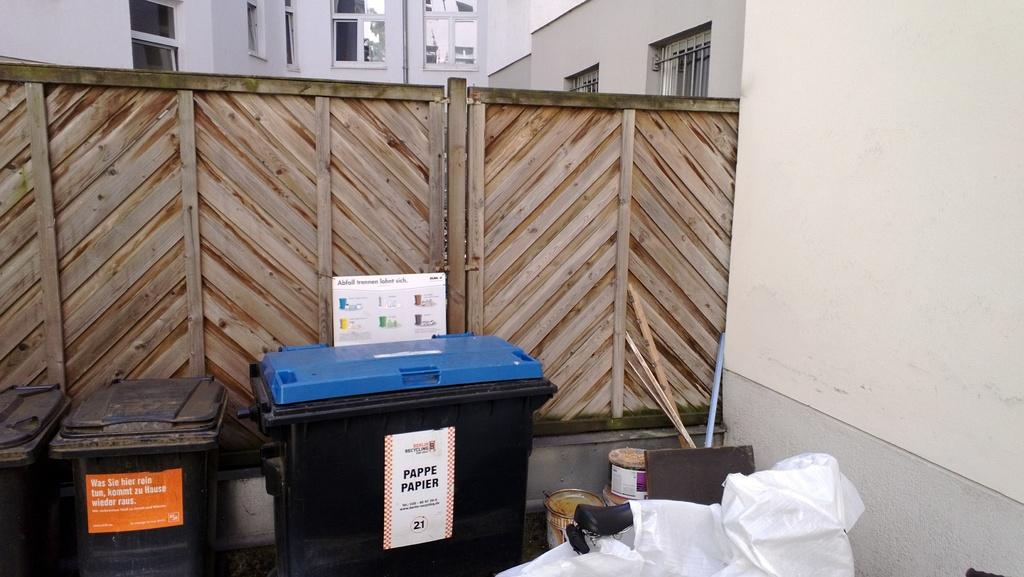<image>
Give a short and clear explanation of the subsequent image. Two trash cans beside a house and one of them has the Pappe Papier sign at the front. 